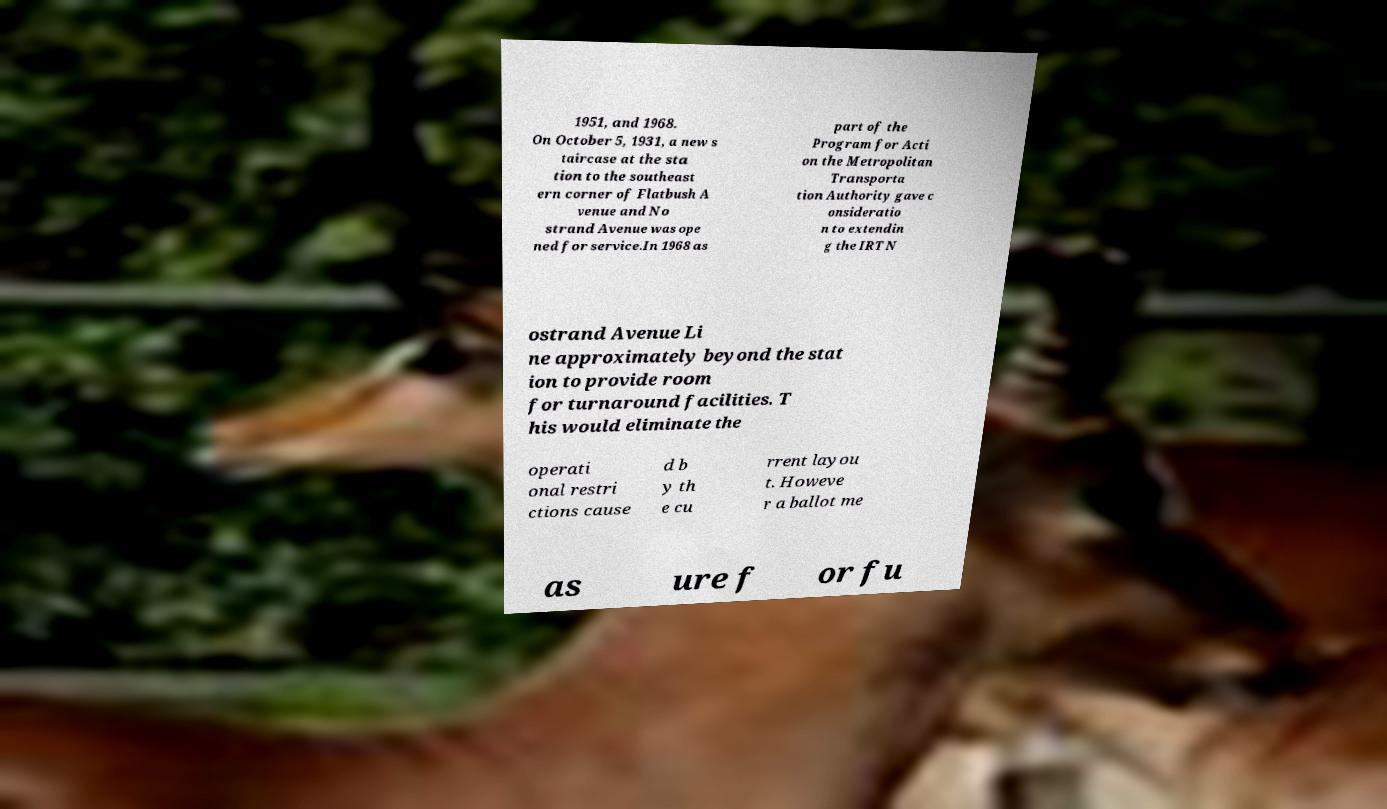For documentation purposes, I need the text within this image transcribed. Could you provide that? 1951, and 1968. On October 5, 1931, a new s taircase at the sta tion to the southeast ern corner of Flatbush A venue and No strand Avenue was ope ned for service.In 1968 as part of the Program for Acti on the Metropolitan Transporta tion Authority gave c onsideratio n to extendin g the IRT N ostrand Avenue Li ne approximately beyond the stat ion to provide room for turnaround facilities. T his would eliminate the operati onal restri ctions cause d b y th e cu rrent layou t. Howeve r a ballot me as ure f or fu 